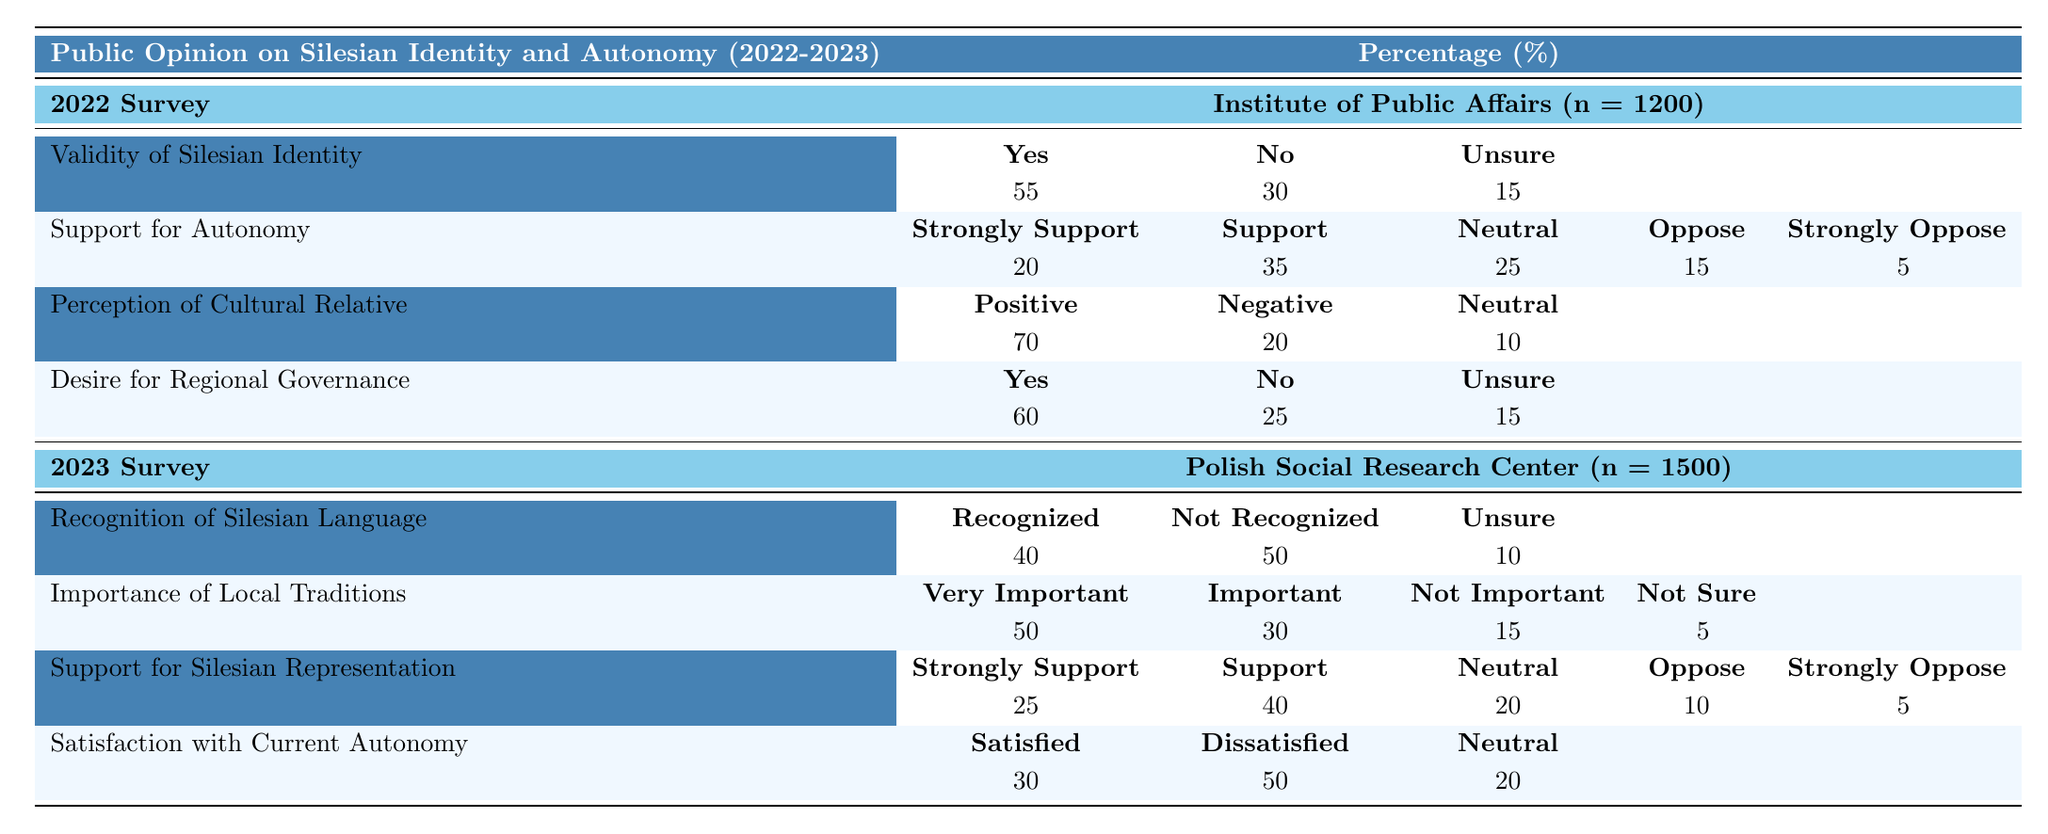What percentage of respondents in 2022 validated Silesian identity? In the 2022 survey, the percentage of respondents who answered "Yes" to the validity of Silesian identity is given directly as 55%.
Answer: 55% What is the total percentage of support (strongly support and support) for Silesian autonomy in 2022? To find the total percentage of support for Silesian autonomy, we add the percentages of "Strongly Support" (20%) and "Support" (35%) together: 20% + 35% = 55%.
Answer: 55% What percentage of respondents in 2023 were dissatisfied with the current autonomy status? In the 2023 survey, the percentage of respondents who reported being "Dissatisfied" is 50%.
Answer: 50% Did a majority of respondents in 2023 consider local traditions to be important? By observing the data, 50% of respondents said "Very Important" and 30% said "Important", totaling 80%, which is indeed a majority.
Answer: Yes What is the difference in satisfaction (satisfied vs dissatisfied) with current autonomy status between 2022 and 2023? In 2022, 0% were explicitly categorized as dissatisfied in the table summary, while in 2023, 50% were dissatisfied. Thus, the difference is 0% (not dissatisfied) - 50% (dissatisfied) = -50%.
Answer: -50% What proportion of 2022 respondents desired regional governance? The percentage of "Yes" responses for the desire for regional governance in 2022 was 60%, indicating this proportion among respondents.
Answer: 60% How does the recognition of the Silesian language in 2023 compare to the validity of Silesian identity in 2022? In 2022, 55% validated Silesian identity (answered "Yes") while in 2023, only 40% recognized the Silesian language. The recognition is lower, indicating a decline in perception.
Answer: Recognition is lower What is the average percentage of support for autonomy across both years? To find the average support, we take the total percentages for "Strongly Support" (20% + 25%) and "Support" (35% + 40%), then average them: (20% + 25% + 35% + 40%) / 4 = 30%.
Answer: 30% What percentage of survey participants in 2023 felt 'Neutral' about Silesian representation in Parliament? In the 2023 survey, the percentage of respondents who felt 'Neutral' about Silesian representation in Parliament is 20%.
Answer: 20% What can be inferred about the trend in satisfaction with autonomy from 2022 to 2023? The satisfaction dropped from 0% (satisfaction unspecified) in 2022 to 30% satisfaction in 2023, indicating a trend of increasing dissatisfaction or at least less satisfaction over time.
Answer: Decreasing satisfaction trend 